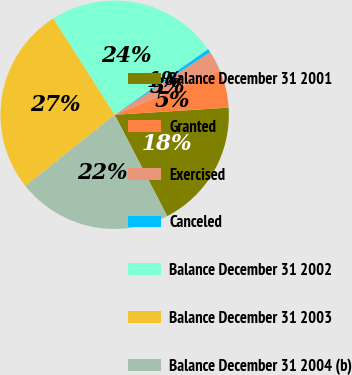<chart> <loc_0><loc_0><loc_500><loc_500><pie_chart><fcel>Balance December 31 2001<fcel>Granted<fcel>Exercised<fcel>Canceled<fcel>Balance December 31 2002<fcel>Balance December 31 2003<fcel>Balance December 31 2004 (b)<nl><fcel>18.38%<fcel>5.33%<fcel>2.92%<fcel>0.51%<fcel>24.29%<fcel>26.7%<fcel>21.88%<nl></chart> 